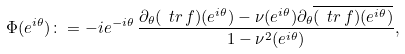Convert formula to latex. <formula><loc_0><loc_0><loc_500><loc_500>\Phi ( e ^ { i \theta } ) \colon = - i e ^ { - i \theta } \, \frac { \partial _ { \theta } ( \ t r \, f ) ( e ^ { i \theta } ) - \nu ( e ^ { i \theta } ) \partial _ { \theta } \overline { ( \ t r \, f ) ( e ^ { i \theta } ) } } { 1 - \nu ^ { 2 } ( e ^ { i \theta } ) } ,</formula> 